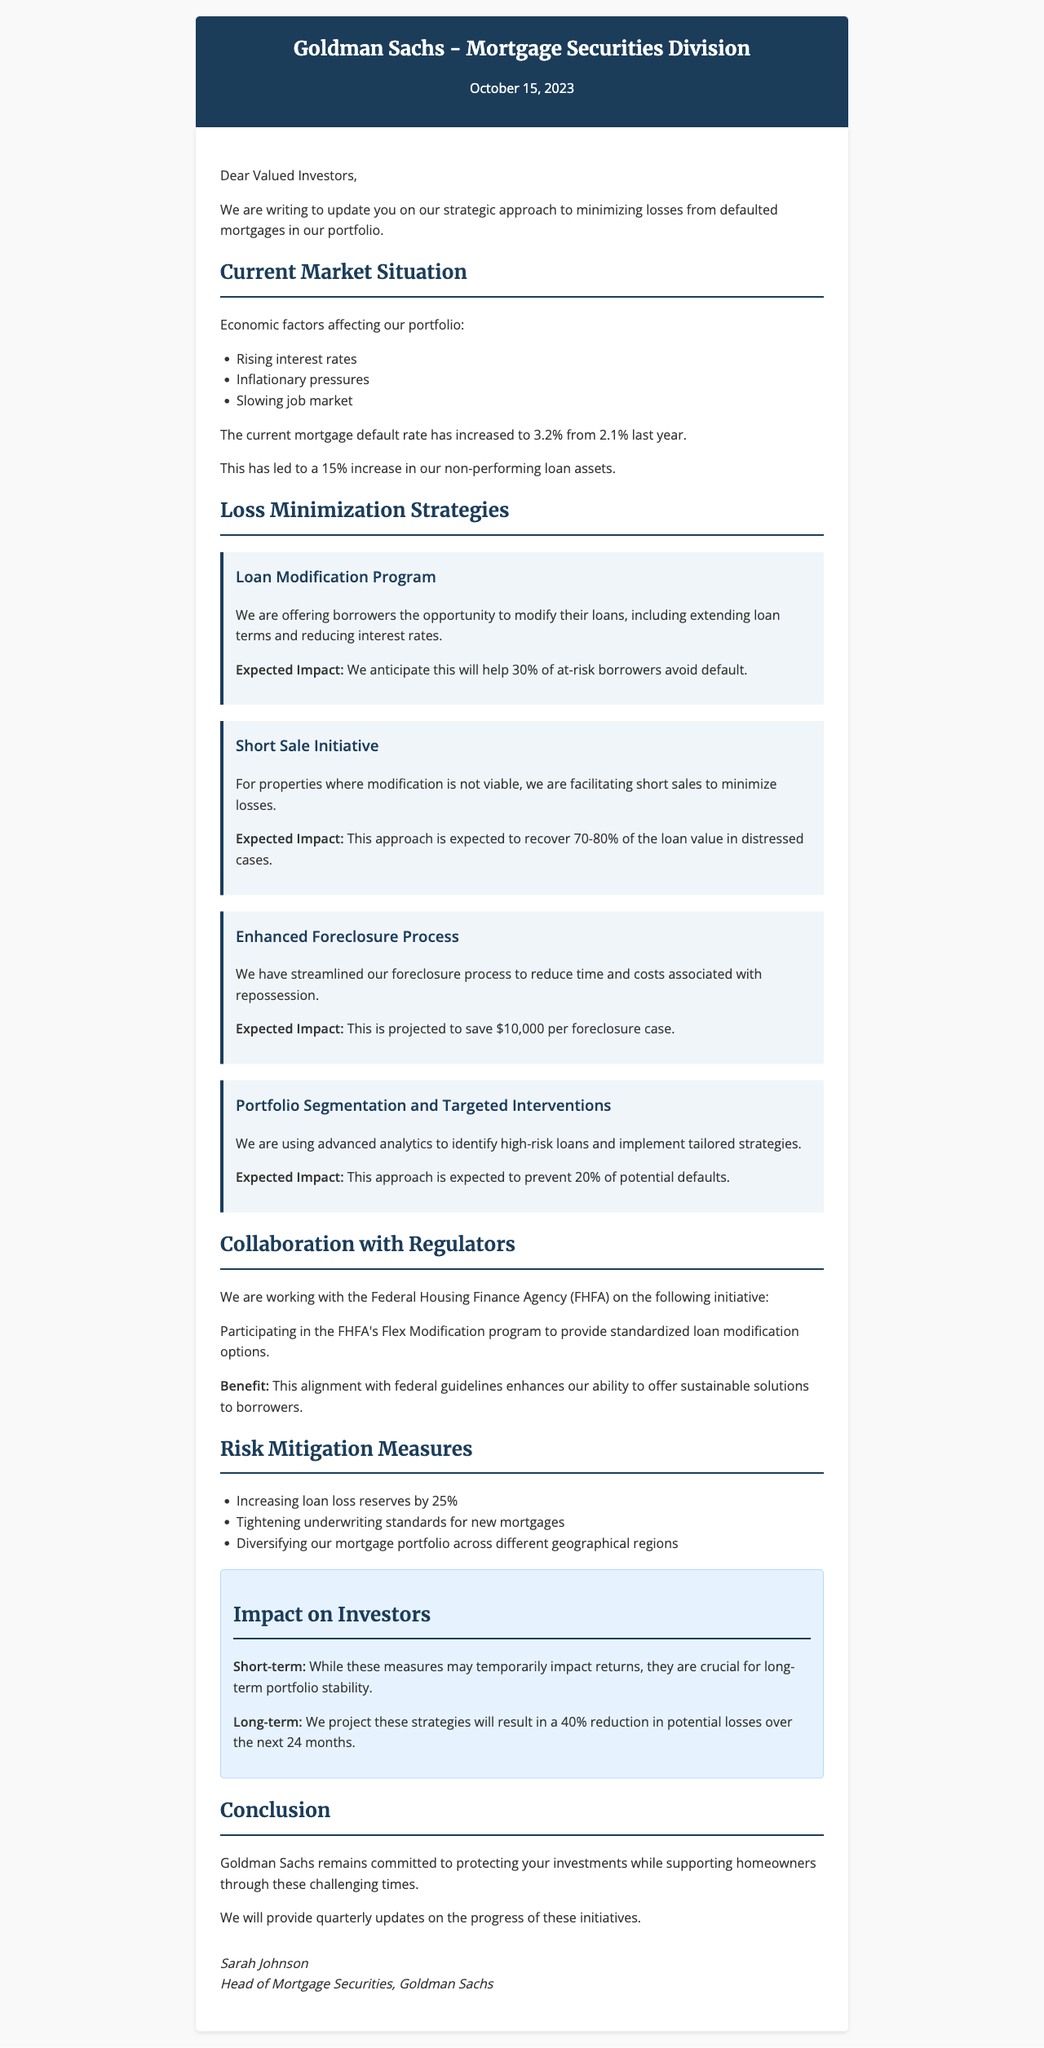What is the current mortgage default rate? The document states that the current mortgage default rate has increased to 3.2% from 2.1% last year.
Answer: 3.2% What is the expected impact of the Loan Modification Program? The expected impact of the Loan Modification Program is to help 30% of at-risk borrowers avoid default.
Answer: 30% What effective action is being taken in collaboration with the FHFA? The document highlights participating in the FHFA's Flex Modification program to provide standardized loan modification options.
Answer: Flex Modification program What is the projected reduction in potential losses over the next 24 months? According to the letter, the projected reduction in potential losses is 40% over the next 24 months.
Answer: 40% What are the three economic factors affecting the portfolio? The document lists rising interest rates, inflationary pressures, and a slowing job market as economic factors.
Answer: Rising interest rates, inflationary pressures, slowing job market What measures are being taken to mitigate risks? The document mentions increasing loan loss reserves, tightening underwriting standards, and diversifying the mortgage portfolio as risk mitigation measures.
Answer: Increasing loan loss reserves by 25% Who signed the letter? The letter is signed by Sarah Johnson, who is the Head of Mortgage Securities at Goldman Sachs.
Answer: Sarah Johnson What is the main commitment stated in the conclusion? The commitment stated is to protect investments while supporting homeowners through challenging times.
Answer: Protecting investments while supporting homeowners 